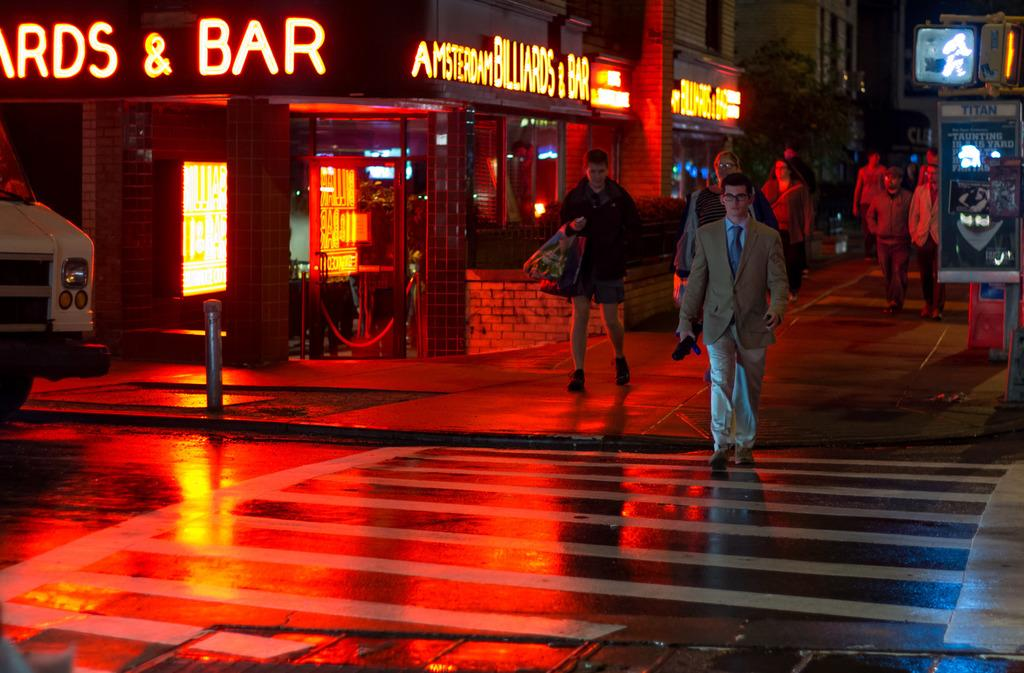What type of structures can be seen in the image? There are buildings with windows in the image. How many people are visible in the image? There are three people visible in the image. What else can be seen on the road in the image? Vehicles are present on the road in the image. What additional feature is present in the image? There is a banner in the image. Are there any servants visible in the image? There is no mention of servants in the image, so we cannot confirm their presence. What type of club is being used in the image? There is no club present in the image. 